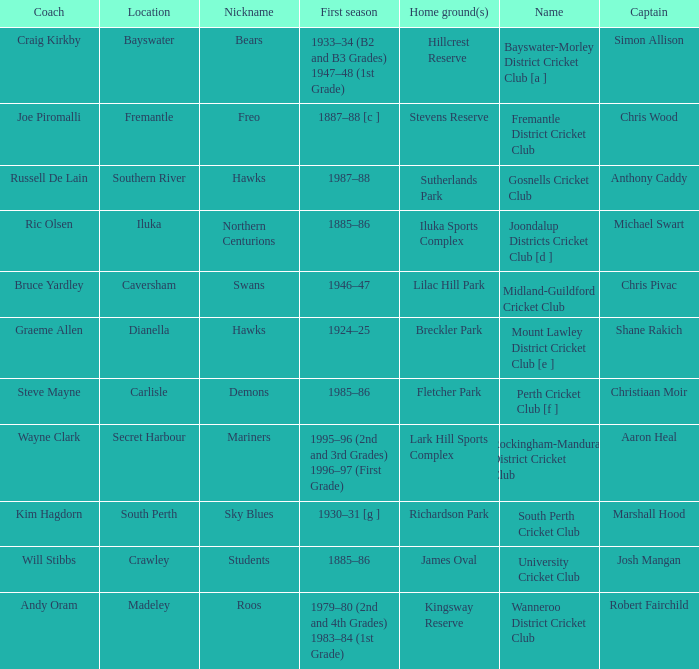What is the dates where Hillcrest Reserve is the home grounds? 1933–34 (B2 and B3 Grades) 1947–48 (1st Grade). 